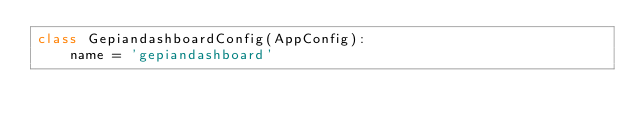<code> <loc_0><loc_0><loc_500><loc_500><_Python_>class GepiandashboardConfig(AppConfig):
    name = 'gepiandashboard'
</code> 